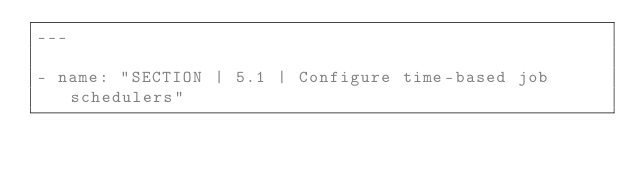Convert code to text. <code><loc_0><loc_0><loc_500><loc_500><_YAML_>---

- name: "SECTION | 5.1 | Configure time-based job schedulers"</code> 